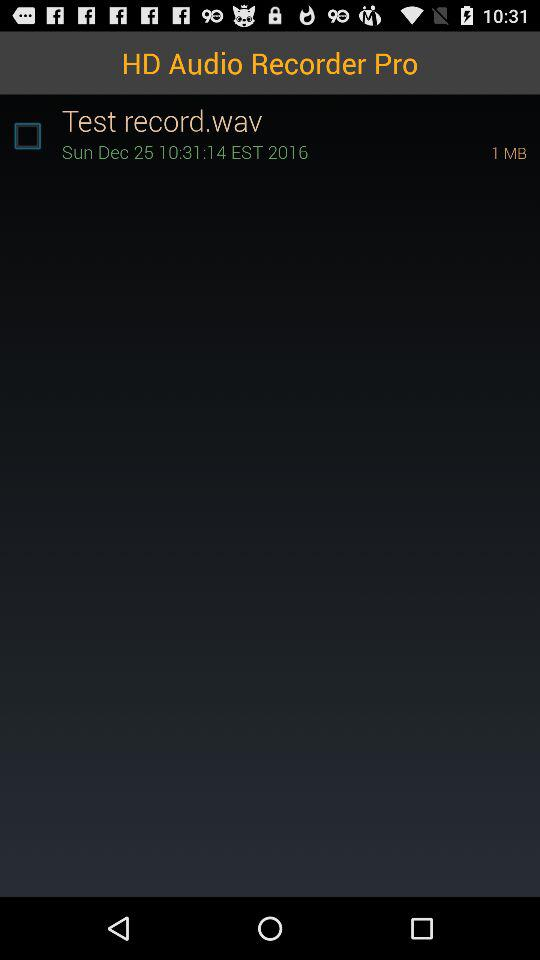What is the name of the application? The name of the application is "HD Audio Recorder Pro". 